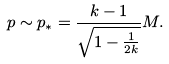<formula> <loc_0><loc_0><loc_500><loc_500>p \sim p _ { * } = \frac { k - 1 } { \sqrt { 1 - \frac { 1 } { 2 k } } } M .</formula> 